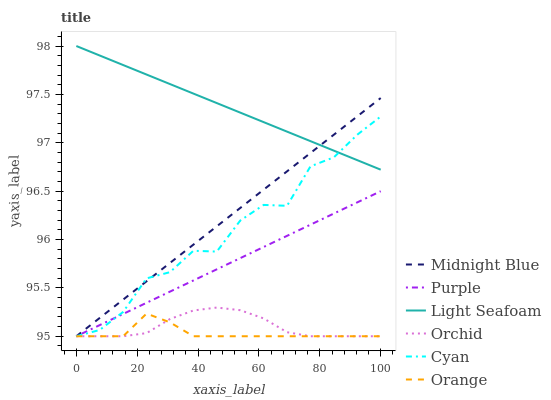Does Purple have the minimum area under the curve?
Answer yes or no. No. Does Purple have the maximum area under the curve?
Answer yes or no. No. Is Purple the smoothest?
Answer yes or no. No. Is Purple the roughest?
Answer yes or no. No. Does Light Seafoam have the lowest value?
Answer yes or no. No. Does Purple have the highest value?
Answer yes or no. No. Is Orchid less than Light Seafoam?
Answer yes or no. Yes. Is Light Seafoam greater than Purple?
Answer yes or no. Yes. Does Orchid intersect Light Seafoam?
Answer yes or no. No. 